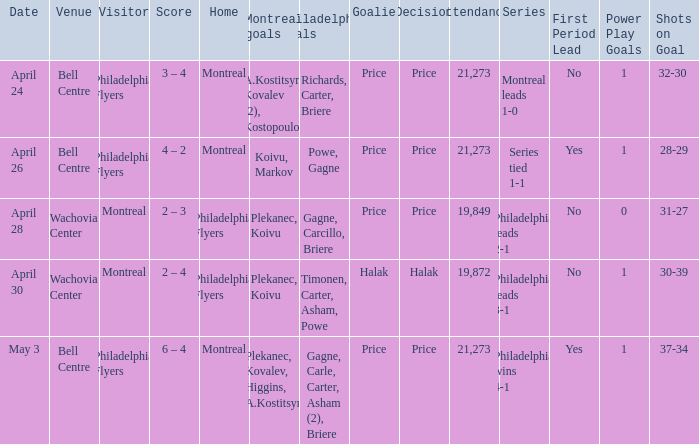What was the average attendance when the decision was price and montreal were the visitors? 19849.0. 